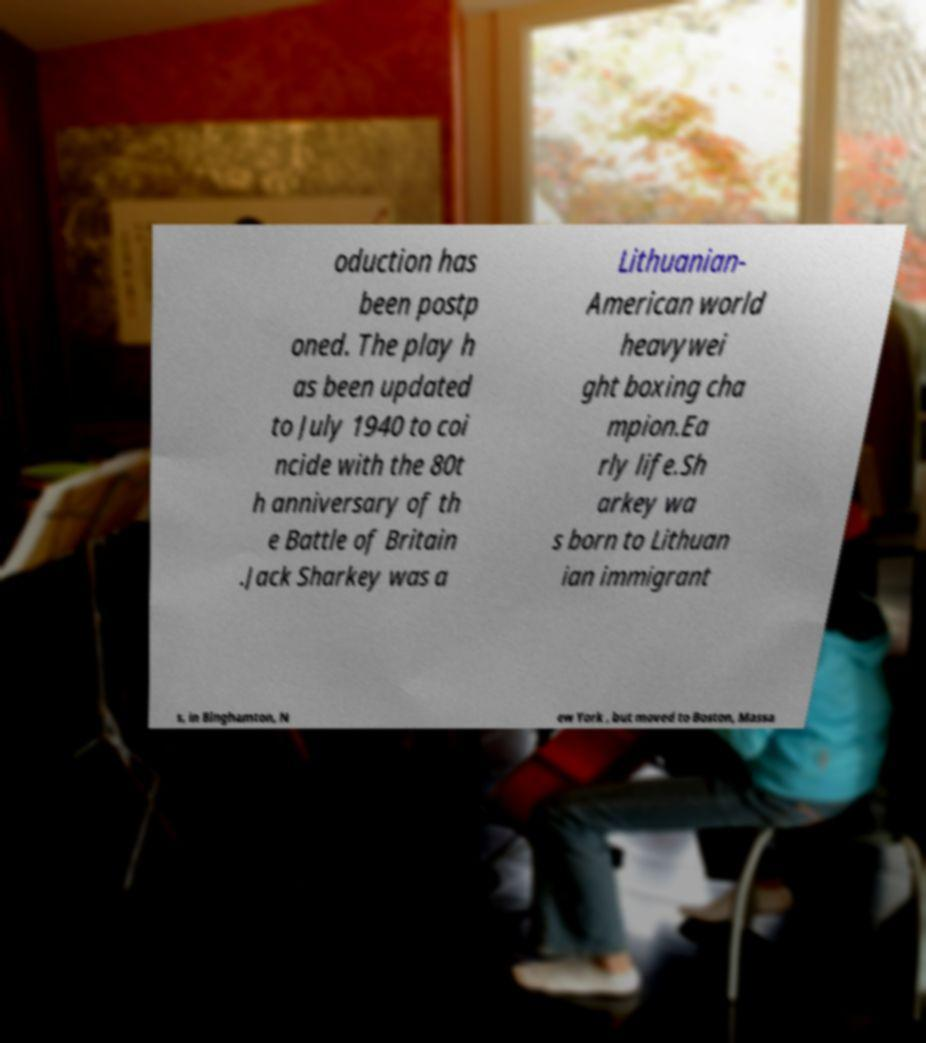For documentation purposes, I need the text within this image transcribed. Could you provide that? oduction has been postp oned. The play h as been updated to July 1940 to coi ncide with the 80t h anniversary of th e Battle of Britain .Jack Sharkey was a Lithuanian- American world heavywei ght boxing cha mpion.Ea rly life.Sh arkey wa s born to Lithuan ian immigrant s, in Binghamton, N ew York , but moved to Boston, Massa 